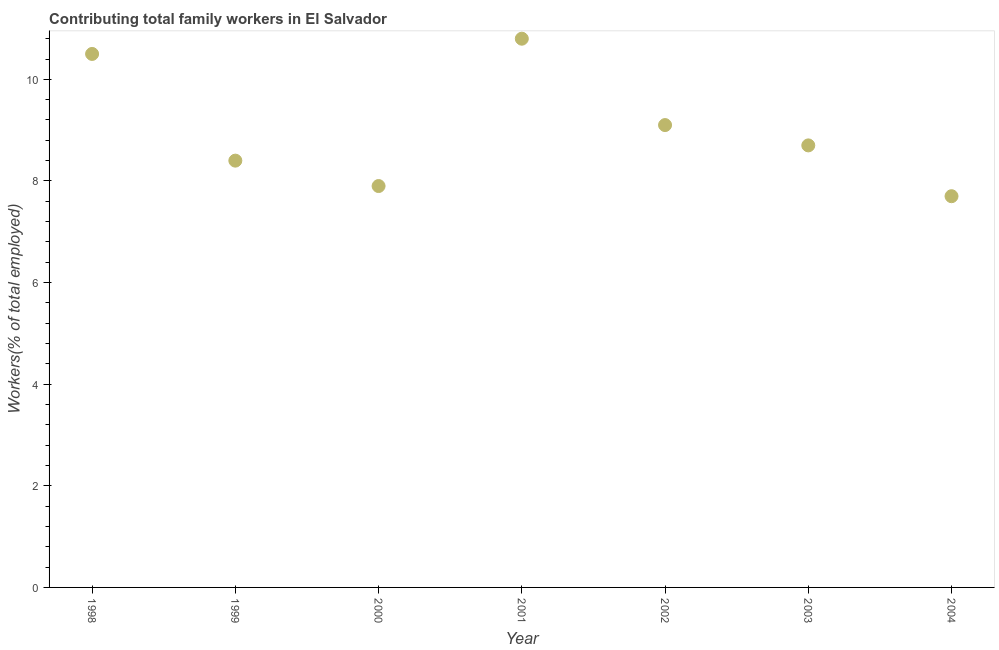What is the contributing family workers in 2001?
Your answer should be very brief. 10.8. Across all years, what is the maximum contributing family workers?
Ensure brevity in your answer.  10.8. Across all years, what is the minimum contributing family workers?
Provide a short and direct response. 7.7. In which year was the contributing family workers maximum?
Your answer should be compact. 2001. In which year was the contributing family workers minimum?
Make the answer very short. 2004. What is the sum of the contributing family workers?
Make the answer very short. 63.1. What is the difference between the contributing family workers in 2002 and 2004?
Your answer should be very brief. 1.4. What is the average contributing family workers per year?
Your answer should be very brief. 9.01. What is the median contributing family workers?
Provide a succinct answer. 8.7. Do a majority of the years between 2001 and 2004 (inclusive) have contributing family workers greater than 3.2 %?
Provide a succinct answer. Yes. What is the ratio of the contributing family workers in 2002 to that in 2004?
Provide a succinct answer. 1.18. What is the difference between the highest and the second highest contributing family workers?
Your answer should be very brief. 0.3. What is the difference between the highest and the lowest contributing family workers?
Provide a succinct answer. 3.1. In how many years, is the contributing family workers greater than the average contributing family workers taken over all years?
Ensure brevity in your answer.  3. How many dotlines are there?
Your response must be concise. 1. How many years are there in the graph?
Offer a very short reply. 7. What is the difference between two consecutive major ticks on the Y-axis?
Provide a succinct answer. 2. What is the title of the graph?
Provide a succinct answer. Contributing total family workers in El Salvador. What is the label or title of the X-axis?
Give a very brief answer. Year. What is the label or title of the Y-axis?
Provide a short and direct response. Workers(% of total employed). What is the Workers(% of total employed) in 1999?
Keep it short and to the point. 8.4. What is the Workers(% of total employed) in 2000?
Ensure brevity in your answer.  7.9. What is the Workers(% of total employed) in 2001?
Your answer should be compact. 10.8. What is the Workers(% of total employed) in 2002?
Make the answer very short. 9.1. What is the Workers(% of total employed) in 2003?
Provide a short and direct response. 8.7. What is the Workers(% of total employed) in 2004?
Keep it short and to the point. 7.7. What is the difference between the Workers(% of total employed) in 1998 and 1999?
Provide a short and direct response. 2.1. What is the difference between the Workers(% of total employed) in 1998 and 2000?
Provide a short and direct response. 2.6. What is the difference between the Workers(% of total employed) in 1998 and 2002?
Your response must be concise. 1.4. What is the difference between the Workers(% of total employed) in 1998 and 2004?
Provide a succinct answer. 2.8. What is the difference between the Workers(% of total employed) in 1999 and 2000?
Your answer should be very brief. 0.5. What is the difference between the Workers(% of total employed) in 1999 and 2001?
Offer a very short reply. -2.4. What is the difference between the Workers(% of total employed) in 2000 and 2001?
Provide a short and direct response. -2.9. What is the difference between the Workers(% of total employed) in 2000 and 2002?
Give a very brief answer. -1.2. What is the difference between the Workers(% of total employed) in 2001 and 2003?
Your response must be concise. 2.1. What is the difference between the Workers(% of total employed) in 2002 and 2003?
Your answer should be compact. 0.4. What is the difference between the Workers(% of total employed) in 2002 and 2004?
Ensure brevity in your answer.  1.4. What is the ratio of the Workers(% of total employed) in 1998 to that in 1999?
Give a very brief answer. 1.25. What is the ratio of the Workers(% of total employed) in 1998 to that in 2000?
Offer a very short reply. 1.33. What is the ratio of the Workers(% of total employed) in 1998 to that in 2002?
Your answer should be very brief. 1.15. What is the ratio of the Workers(% of total employed) in 1998 to that in 2003?
Make the answer very short. 1.21. What is the ratio of the Workers(% of total employed) in 1998 to that in 2004?
Give a very brief answer. 1.36. What is the ratio of the Workers(% of total employed) in 1999 to that in 2000?
Provide a short and direct response. 1.06. What is the ratio of the Workers(% of total employed) in 1999 to that in 2001?
Offer a very short reply. 0.78. What is the ratio of the Workers(% of total employed) in 1999 to that in 2002?
Offer a very short reply. 0.92. What is the ratio of the Workers(% of total employed) in 1999 to that in 2004?
Give a very brief answer. 1.09. What is the ratio of the Workers(% of total employed) in 2000 to that in 2001?
Provide a short and direct response. 0.73. What is the ratio of the Workers(% of total employed) in 2000 to that in 2002?
Your answer should be very brief. 0.87. What is the ratio of the Workers(% of total employed) in 2000 to that in 2003?
Offer a very short reply. 0.91. What is the ratio of the Workers(% of total employed) in 2001 to that in 2002?
Provide a succinct answer. 1.19. What is the ratio of the Workers(% of total employed) in 2001 to that in 2003?
Provide a short and direct response. 1.24. What is the ratio of the Workers(% of total employed) in 2001 to that in 2004?
Keep it short and to the point. 1.4. What is the ratio of the Workers(% of total employed) in 2002 to that in 2003?
Provide a short and direct response. 1.05. What is the ratio of the Workers(% of total employed) in 2002 to that in 2004?
Make the answer very short. 1.18. What is the ratio of the Workers(% of total employed) in 2003 to that in 2004?
Keep it short and to the point. 1.13. 